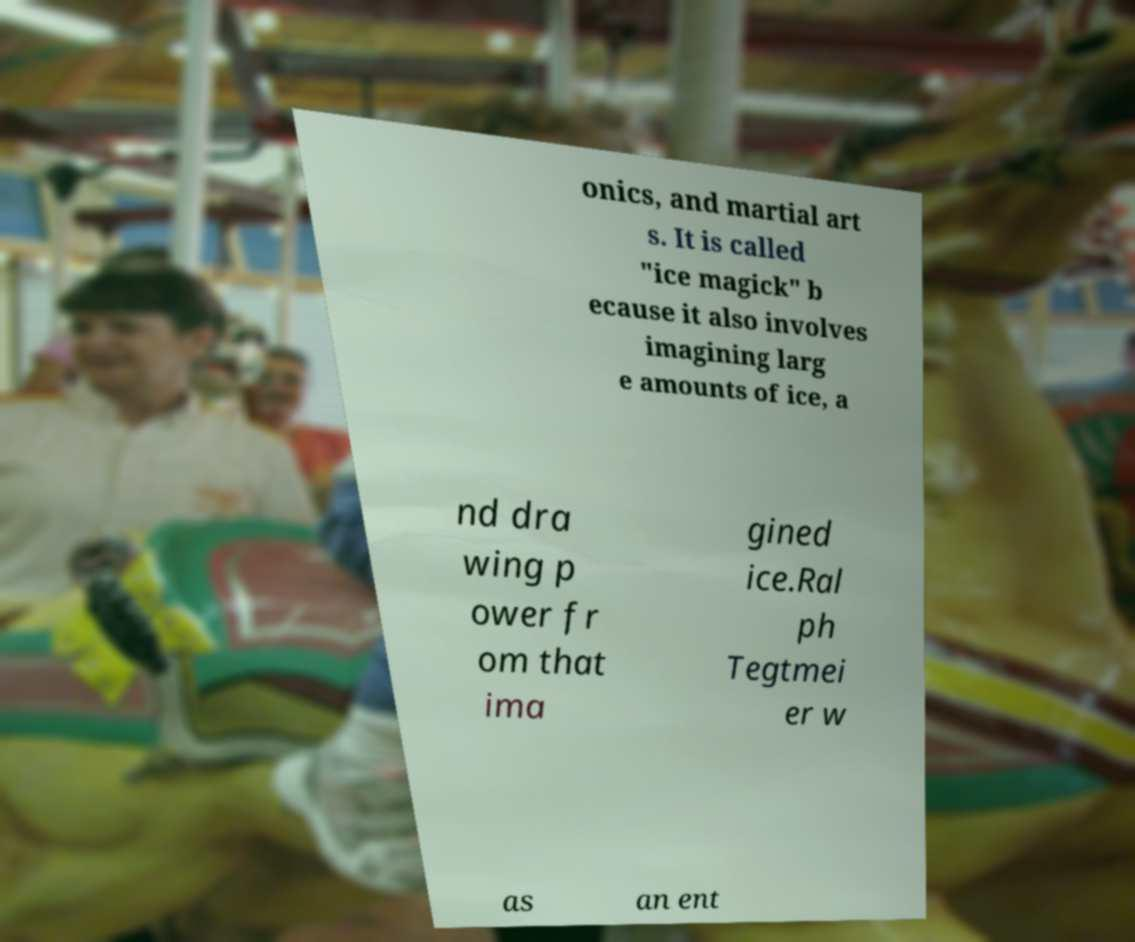Please read and relay the text visible in this image. What does it say? onics, and martial art s. It is called "ice magick" b ecause it also involves imagining larg e amounts of ice, a nd dra wing p ower fr om that ima gined ice.Ral ph Tegtmei er w as an ent 